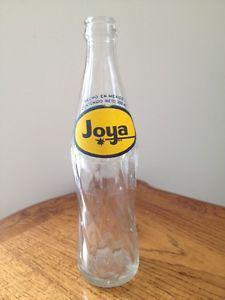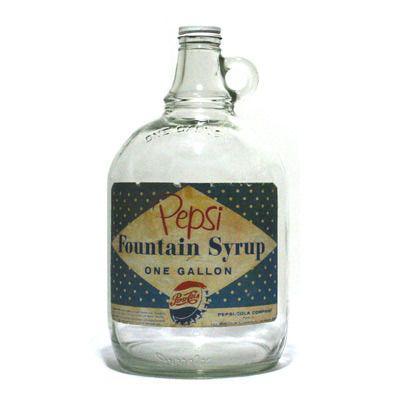The first image is the image on the left, the second image is the image on the right. Given the left and right images, does the statement "there are two glass containers in the image pair" hold true? Answer yes or no. Yes. The first image is the image on the left, the second image is the image on the right. Evaluate the accuracy of this statement regarding the images: "the left and right image contains the same number of glass bottles.". Is it true? Answer yes or no. Yes. 